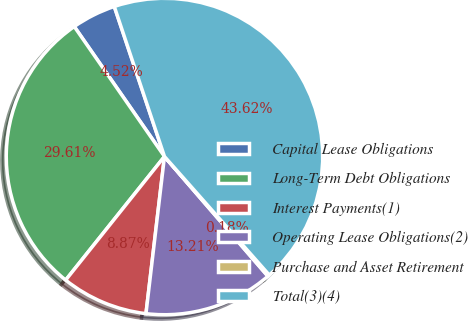Convert chart to OTSL. <chart><loc_0><loc_0><loc_500><loc_500><pie_chart><fcel>Capital Lease Obligations<fcel>Long-Term Debt Obligations<fcel>Interest Payments(1)<fcel>Operating Lease Obligations(2)<fcel>Purchase and Asset Retirement<fcel>Total(3)(4)<nl><fcel>4.52%<fcel>29.61%<fcel>8.87%<fcel>13.21%<fcel>0.18%<fcel>43.62%<nl></chart> 